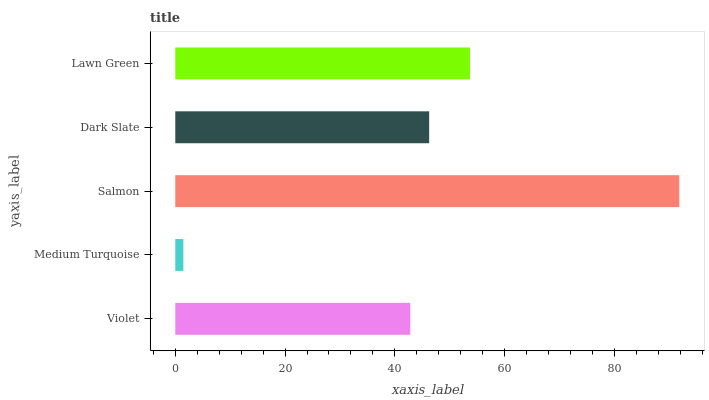Is Medium Turquoise the minimum?
Answer yes or no. Yes. Is Salmon the maximum?
Answer yes or no. Yes. Is Salmon the minimum?
Answer yes or no. No. Is Medium Turquoise the maximum?
Answer yes or no. No. Is Salmon greater than Medium Turquoise?
Answer yes or no. Yes. Is Medium Turquoise less than Salmon?
Answer yes or no. Yes. Is Medium Turquoise greater than Salmon?
Answer yes or no. No. Is Salmon less than Medium Turquoise?
Answer yes or no. No. Is Dark Slate the high median?
Answer yes or no. Yes. Is Dark Slate the low median?
Answer yes or no. Yes. Is Violet the high median?
Answer yes or no. No. Is Medium Turquoise the low median?
Answer yes or no. No. 